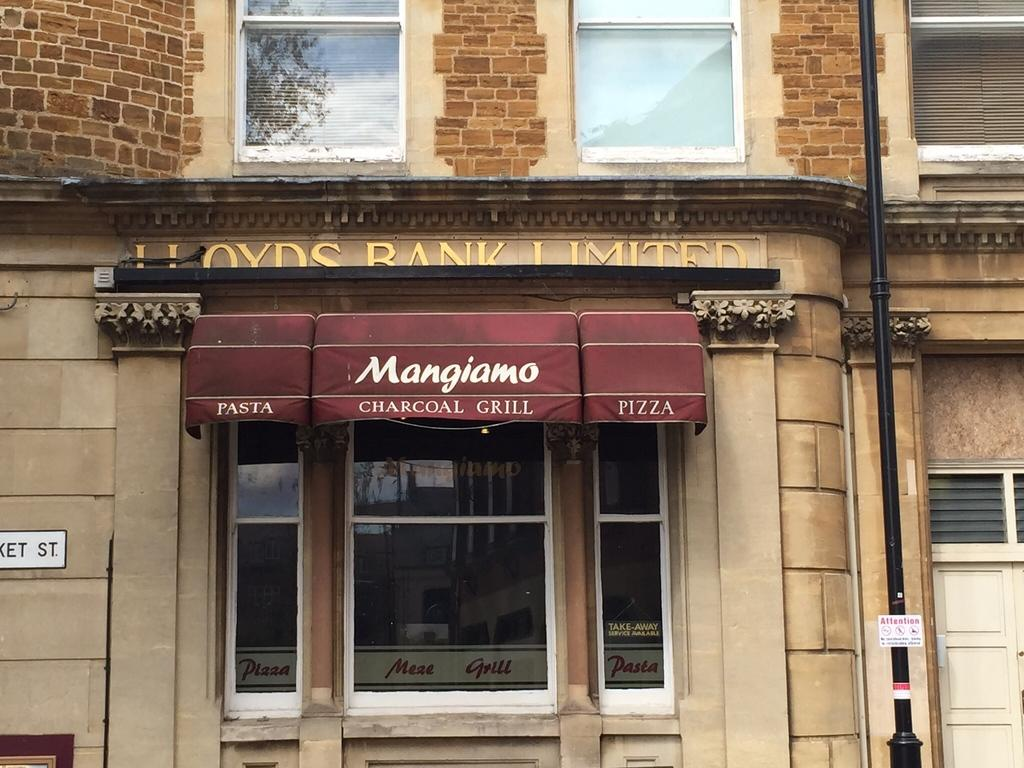What type of structure is visible in the image? There is a building in the image. How can the building be identified? The building has a name board at the front. What else can be seen in the image besides the building? There is a pole in the image. What is the reflection of in a window of the building? There is a reflection of trees in a window of the building. What type of division can be seen in the image? There is no division present in the image; it features a building, a pole, and a reflection of trees in a window. What kind of paper is being used to write on in the image? There is no paper visible in the image, and no writing activity is taking place. 